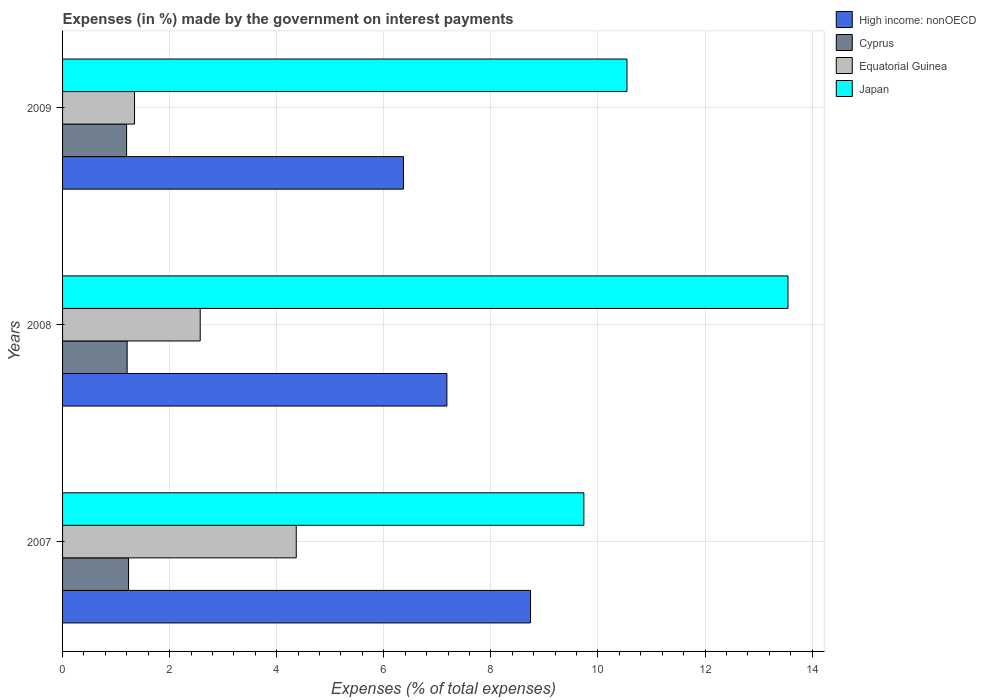How many different coloured bars are there?
Ensure brevity in your answer.  4. How many groups of bars are there?
Offer a terse response. 3. Are the number of bars per tick equal to the number of legend labels?
Your answer should be very brief. Yes. How many bars are there on the 3rd tick from the top?
Offer a very short reply. 4. How many bars are there on the 1st tick from the bottom?
Ensure brevity in your answer.  4. In how many cases, is the number of bars for a given year not equal to the number of legend labels?
Provide a short and direct response. 0. What is the percentage of expenses made by the government on interest payments in Japan in 2007?
Your response must be concise. 9.74. Across all years, what is the maximum percentage of expenses made by the government on interest payments in Equatorial Guinea?
Your answer should be compact. 4.36. Across all years, what is the minimum percentage of expenses made by the government on interest payments in Equatorial Guinea?
Make the answer very short. 1.34. In which year was the percentage of expenses made by the government on interest payments in High income: nonOECD maximum?
Provide a short and direct response. 2007. In which year was the percentage of expenses made by the government on interest payments in Cyprus minimum?
Offer a very short reply. 2009. What is the total percentage of expenses made by the government on interest payments in Equatorial Guinea in the graph?
Your answer should be compact. 8.28. What is the difference between the percentage of expenses made by the government on interest payments in Japan in 2008 and that in 2009?
Provide a short and direct response. 3.01. What is the difference between the percentage of expenses made by the government on interest payments in Equatorial Guinea in 2009 and the percentage of expenses made by the government on interest payments in High income: nonOECD in 2007?
Offer a very short reply. -7.4. What is the average percentage of expenses made by the government on interest payments in Cyprus per year?
Make the answer very short. 1.21. In the year 2008, what is the difference between the percentage of expenses made by the government on interest payments in Equatorial Guinea and percentage of expenses made by the government on interest payments in Japan?
Ensure brevity in your answer.  -10.98. In how many years, is the percentage of expenses made by the government on interest payments in High income: nonOECD greater than 13.2 %?
Provide a short and direct response. 0. What is the ratio of the percentage of expenses made by the government on interest payments in Cyprus in 2007 to that in 2008?
Provide a succinct answer. 1.02. Is the difference between the percentage of expenses made by the government on interest payments in Equatorial Guinea in 2007 and 2009 greater than the difference between the percentage of expenses made by the government on interest payments in Japan in 2007 and 2009?
Offer a terse response. Yes. What is the difference between the highest and the second highest percentage of expenses made by the government on interest payments in Japan?
Offer a very short reply. 3.01. What is the difference between the highest and the lowest percentage of expenses made by the government on interest payments in Japan?
Your answer should be compact. 3.81. In how many years, is the percentage of expenses made by the government on interest payments in Equatorial Guinea greater than the average percentage of expenses made by the government on interest payments in Equatorial Guinea taken over all years?
Your answer should be very brief. 1. Is it the case that in every year, the sum of the percentage of expenses made by the government on interest payments in Japan and percentage of expenses made by the government on interest payments in High income: nonOECD is greater than the sum of percentage of expenses made by the government on interest payments in Equatorial Guinea and percentage of expenses made by the government on interest payments in Cyprus?
Keep it short and to the point. No. What does the 2nd bar from the bottom in 2009 represents?
Your response must be concise. Cyprus. Are all the bars in the graph horizontal?
Your response must be concise. Yes. What is the difference between two consecutive major ticks on the X-axis?
Give a very brief answer. 2. Does the graph contain any zero values?
Keep it short and to the point. No. Where does the legend appear in the graph?
Give a very brief answer. Top right. How are the legend labels stacked?
Your answer should be very brief. Vertical. What is the title of the graph?
Your answer should be compact. Expenses (in %) made by the government on interest payments. What is the label or title of the X-axis?
Provide a short and direct response. Expenses (% of total expenses). What is the label or title of the Y-axis?
Ensure brevity in your answer.  Years. What is the Expenses (% of total expenses) of High income: nonOECD in 2007?
Your answer should be very brief. 8.74. What is the Expenses (% of total expenses) of Cyprus in 2007?
Your answer should be compact. 1.23. What is the Expenses (% of total expenses) of Equatorial Guinea in 2007?
Provide a short and direct response. 4.36. What is the Expenses (% of total expenses) in Japan in 2007?
Provide a short and direct response. 9.74. What is the Expenses (% of total expenses) of High income: nonOECD in 2008?
Provide a succinct answer. 7.18. What is the Expenses (% of total expenses) in Cyprus in 2008?
Your response must be concise. 1.21. What is the Expenses (% of total expenses) of Equatorial Guinea in 2008?
Provide a short and direct response. 2.57. What is the Expenses (% of total expenses) in Japan in 2008?
Ensure brevity in your answer.  13.55. What is the Expenses (% of total expenses) of High income: nonOECD in 2009?
Your response must be concise. 6.37. What is the Expenses (% of total expenses) in Cyprus in 2009?
Provide a succinct answer. 1.2. What is the Expenses (% of total expenses) in Equatorial Guinea in 2009?
Provide a succinct answer. 1.34. What is the Expenses (% of total expenses) in Japan in 2009?
Ensure brevity in your answer.  10.54. Across all years, what is the maximum Expenses (% of total expenses) of High income: nonOECD?
Your answer should be compact. 8.74. Across all years, what is the maximum Expenses (% of total expenses) in Cyprus?
Your answer should be compact. 1.23. Across all years, what is the maximum Expenses (% of total expenses) of Equatorial Guinea?
Offer a very short reply. 4.36. Across all years, what is the maximum Expenses (% of total expenses) of Japan?
Keep it short and to the point. 13.55. Across all years, what is the minimum Expenses (% of total expenses) of High income: nonOECD?
Your response must be concise. 6.37. Across all years, what is the minimum Expenses (% of total expenses) in Cyprus?
Offer a terse response. 1.2. Across all years, what is the minimum Expenses (% of total expenses) in Equatorial Guinea?
Ensure brevity in your answer.  1.34. Across all years, what is the minimum Expenses (% of total expenses) of Japan?
Give a very brief answer. 9.74. What is the total Expenses (% of total expenses) of High income: nonOECD in the graph?
Ensure brevity in your answer.  22.29. What is the total Expenses (% of total expenses) in Cyprus in the graph?
Offer a very short reply. 3.63. What is the total Expenses (% of total expenses) in Equatorial Guinea in the graph?
Your answer should be compact. 8.28. What is the total Expenses (% of total expenses) of Japan in the graph?
Make the answer very short. 33.83. What is the difference between the Expenses (% of total expenses) in High income: nonOECD in 2007 and that in 2008?
Give a very brief answer. 1.56. What is the difference between the Expenses (% of total expenses) in Cyprus in 2007 and that in 2008?
Your answer should be very brief. 0.03. What is the difference between the Expenses (% of total expenses) in Equatorial Guinea in 2007 and that in 2008?
Provide a short and direct response. 1.79. What is the difference between the Expenses (% of total expenses) in Japan in 2007 and that in 2008?
Your answer should be compact. -3.81. What is the difference between the Expenses (% of total expenses) in High income: nonOECD in 2007 and that in 2009?
Your response must be concise. 2.37. What is the difference between the Expenses (% of total expenses) of Cyprus in 2007 and that in 2009?
Offer a very short reply. 0.04. What is the difference between the Expenses (% of total expenses) of Equatorial Guinea in 2007 and that in 2009?
Offer a terse response. 3.02. What is the difference between the Expenses (% of total expenses) of Japan in 2007 and that in 2009?
Provide a succinct answer. -0.81. What is the difference between the Expenses (% of total expenses) in High income: nonOECD in 2008 and that in 2009?
Offer a very short reply. 0.81. What is the difference between the Expenses (% of total expenses) of Cyprus in 2008 and that in 2009?
Offer a terse response. 0.01. What is the difference between the Expenses (% of total expenses) of Equatorial Guinea in 2008 and that in 2009?
Your answer should be compact. 1.23. What is the difference between the Expenses (% of total expenses) in Japan in 2008 and that in 2009?
Your response must be concise. 3.01. What is the difference between the Expenses (% of total expenses) of High income: nonOECD in 2007 and the Expenses (% of total expenses) of Cyprus in 2008?
Your answer should be compact. 7.53. What is the difference between the Expenses (% of total expenses) of High income: nonOECD in 2007 and the Expenses (% of total expenses) of Equatorial Guinea in 2008?
Give a very brief answer. 6.17. What is the difference between the Expenses (% of total expenses) of High income: nonOECD in 2007 and the Expenses (% of total expenses) of Japan in 2008?
Your answer should be compact. -4.81. What is the difference between the Expenses (% of total expenses) of Cyprus in 2007 and the Expenses (% of total expenses) of Equatorial Guinea in 2008?
Your answer should be very brief. -1.34. What is the difference between the Expenses (% of total expenses) of Cyprus in 2007 and the Expenses (% of total expenses) of Japan in 2008?
Your response must be concise. -12.32. What is the difference between the Expenses (% of total expenses) of Equatorial Guinea in 2007 and the Expenses (% of total expenses) of Japan in 2008?
Your answer should be very brief. -9.18. What is the difference between the Expenses (% of total expenses) in High income: nonOECD in 2007 and the Expenses (% of total expenses) in Cyprus in 2009?
Keep it short and to the point. 7.54. What is the difference between the Expenses (% of total expenses) in High income: nonOECD in 2007 and the Expenses (% of total expenses) in Equatorial Guinea in 2009?
Provide a succinct answer. 7.4. What is the difference between the Expenses (% of total expenses) in High income: nonOECD in 2007 and the Expenses (% of total expenses) in Japan in 2009?
Keep it short and to the point. -1.8. What is the difference between the Expenses (% of total expenses) of Cyprus in 2007 and the Expenses (% of total expenses) of Equatorial Guinea in 2009?
Provide a short and direct response. -0.11. What is the difference between the Expenses (% of total expenses) in Cyprus in 2007 and the Expenses (% of total expenses) in Japan in 2009?
Offer a very short reply. -9.31. What is the difference between the Expenses (% of total expenses) of Equatorial Guinea in 2007 and the Expenses (% of total expenses) of Japan in 2009?
Make the answer very short. -6.18. What is the difference between the Expenses (% of total expenses) in High income: nonOECD in 2008 and the Expenses (% of total expenses) in Cyprus in 2009?
Provide a succinct answer. 5.98. What is the difference between the Expenses (% of total expenses) in High income: nonOECD in 2008 and the Expenses (% of total expenses) in Equatorial Guinea in 2009?
Your response must be concise. 5.83. What is the difference between the Expenses (% of total expenses) of High income: nonOECD in 2008 and the Expenses (% of total expenses) of Japan in 2009?
Provide a short and direct response. -3.36. What is the difference between the Expenses (% of total expenses) of Cyprus in 2008 and the Expenses (% of total expenses) of Equatorial Guinea in 2009?
Your answer should be compact. -0.14. What is the difference between the Expenses (% of total expenses) in Cyprus in 2008 and the Expenses (% of total expenses) in Japan in 2009?
Your answer should be very brief. -9.34. What is the difference between the Expenses (% of total expenses) in Equatorial Guinea in 2008 and the Expenses (% of total expenses) in Japan in 2009?
Provide a succinct answer. -7.97. What is the average Expenses (% of total expenses) in High income: nonOECD per year?
Keep it short and to the point. 7.43. What is the average Expenses (% of total expenses) in Cyprus per year?
Your answer should be compact. 1.21. What is the average Expenses (% of total expenses) in Equatorial Guinea per year?
Your answer should be compact. 2.76. What is the average Expenses (% of total expenses) in Japan per year?
Your answer should be very brief. 11.28. In the year 2007, what is the difference between the Expenses (% of total expenses) in High income: nonOECD and Expenses (% of total expenses) in Cyprus?
Your response must be concise. 7.51. In the year 2007, what is the difference between the Expenses (% of total expenses) in High income: nonOECD and Expenses (% of total expenses) in Equatorial Guinea?
Keep it short and to the point. 4.38. In the year 2007, what is the difference between the Expenses (% of total expenses) in High income: nonOECD and Expenses (% of total expenses) in Japan?
Provide a succinct answer. -1. In the year 2007, what is the difference between the Expenses (% of total expenses) of Cyprus and Expenses (% of total expenses) of Equatorial Guinea?
Ensure brevity in your answer.  -3.13. In the year 2007, what is the difference between the Expenses (% of total expenses) of Cyprus and Expenses (% of total expenses) of Japan?
Ensure brevity in your answer.  -8.5. In the year 2007, what is the difference between the Expenses (% of total expenses) of Equatorial Guinea and Expenses (% of total expenses) of Japan?
Your answer should be compact. -5.37. In the year 2008, what is the difference between the Expenses (% of total expenses) in High income: nonOECD and Expenses (% of total expenses) in Cyprus?
Offer a very short reply. 5.97. In the year 2008, what is the difference between the Expenses (% of total expenses) in High income: nonOECD and Expenses (% of total expenses) in Equatorial Guinea?
Ensure brevity in your answer.  4.61. In the year 2008, what is the difference between the Expenses (% of total expenses) of High income: nonOECD and Expenses (% of total expenses) of Japan?
Make the answer very short. -6.37. In the year 2008, what is the difference between the Expenses (% of total expenses) of Cyprus and Expenses (% of total expenses) of Equatorial Guinea?
Your answer should be very brief. -1.36. In the year 2008, what is the difference between the Expenses (% of total expenses) in Cyprus and Expenses (% of total expenses) in Japan?
Give a very brief answer. -12.34. In the year 2008, what is the difference between the Expenses (% of total expenses) in Equatorial Guinea and Expenses (% of total expenses) in Japan?
Provide a succinct answer. -10.98. In the year 2009, what is the difference between the Expenses (% of total expenses) of High income: nonOECD and Expenses (% of total expenses) of Cyprus?
Your answer should be very brief. 5.17. In the year 2009, what is the difference between the Expenses (% of total expenses) of High income: nonOECD and Expenses (% of total expenses) of Equatorial Guinea?
Offer a terse response. 5.02. In the year 2009, what is the difference between the Expenses (% of total expenses) in High income: nonOECD and Expenses (% of total expenses) in Japan?
Offer a very short reply. -4.17. In the year 2009, what is the difference between the Expenses (% of total expenses) in Cyprus and Expenses (% of total expenses) in Equatorial Guinea?
Offer a terse response. -0.15. In the year 2009, what is the difference between the Expenses (% of total expenses) in Cyprus and Expenses (% of total expenses) in Japan?
Offer a very short reply. -9.35. In the year 2009, what is the difference between the Expenses (% of total expenses) of Equatorial Guinea and Expenses (% of total expenses) of Japan?
Provide a short and direct response. -9.2. What is the ratio of the Expenses (% of total expenses) in High income: nonOECD in 2007 to that in 2008?
Give a very brief answer. 1.22. What is the ratio of the Expenses (% of total expenses) of Cyprus in 2007 to that in 2008?
Keep it short and to the point. 1.02. What is the ratio of the Expenses (% of total expenses) of Equatorial Guinea in 2007 to that in 2008?
Your answer should be compact. 1.7. What is the ratio of the Expenses (% of total expenses) in Japan in 2007 to that in 2008?
Provide a short and direct response. 0.72. What is the ratio of the Expenses (% of total expenses) in High income: nonOECD in 2007 to that in 2009?
Ensure brevity in your answer.  1.37. What is the ratio of the Expenses (% of total expenses) in Cyprus in 2007 to that in 2009?
Provide a succinct answer. 1.03. What is the ratio of the Expenses (% of total expenses) of Equatorial Guinea in 2007 to that in 2009?
Keep it short and to the point. 3.25. What is the ratio of the Expenses (% of total expenses) of Japan in 2007 to that in 2009?
Give a very brief answer. 0.92. What is the ratio of the Expenses (% of total expenses) of High income: nonOECD in 2008 to that in 2009?
Give a very brief answer. 1.13. What is the ratio of the Expenses (% of total expenses) of Cyprus in 2008 to that in 2009?
Give a very brief answer. 1.01. What is the ratio of the Expenses (% of total expenses) in Equatorial Guinea in 2008 to that in 2009?
Offer a terse response. 1.91. What is the ratio of the Expenses (% of total expenses) of Japan in 2008 to that in 2009?
Ensure brevity in your answer.  1.29. What is the difference between the highest and the second highest Expenses (% of total expenses) in High income: nonOECD?
Provide a short and direct response. 1.56. What is the difference between the highest and the second highest Expenses (% of total expenses) of Cyprus?
Your response must be concise. 0.03. What is the difference between the highest and the second highest Expenses (% of total expenses) in Equatorial Guinea?
Provide a short and direct response. 1.79. What is the difference between the highest and the second highest Expenses (% of total expenses) in Japan?
Your answer should be compact. 3.01. What is the difference between the highest and the lowest Expenses (% of total expenses) in High income: nonOECD?
Make the answer very short. 2.37. What is the difference between the highest and the lowest Expenses (% of total expenses) of Cyprus?
Offer a terse response. 0.04. What is the difference between the highest and the lowest Expenses (% of total expenses) of Equatorial Guinea?
Keep it short and to the point. 3.02. What is the difference between the highest and the lowest Expenses (% of total expenses) of Japan?
Your answer should be compact. 3.81. 